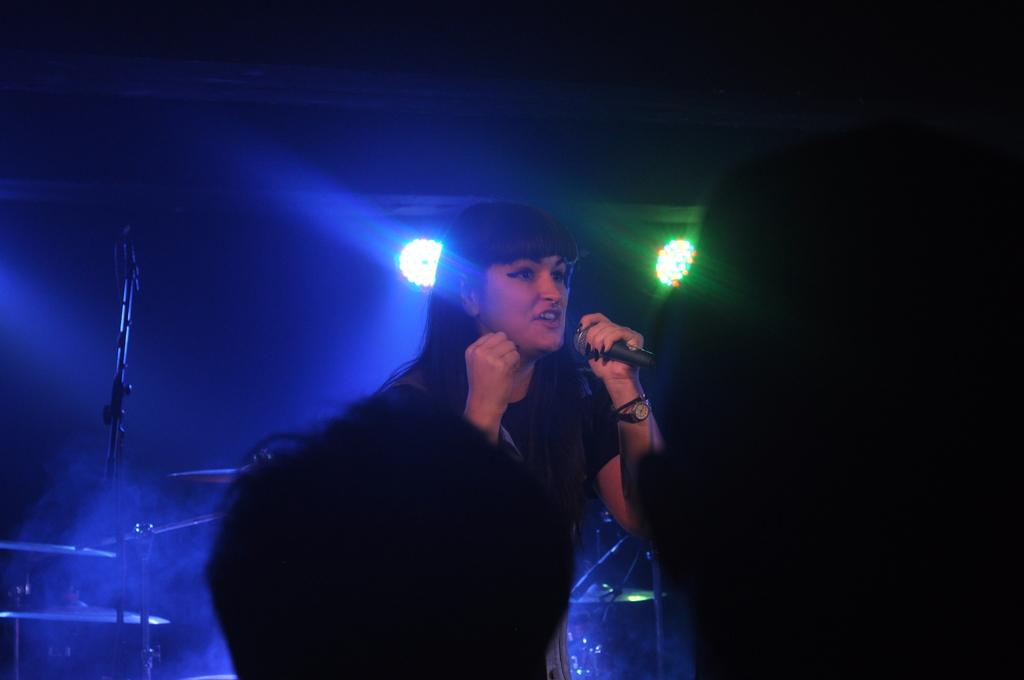What is the person in the image doing? The person is standing and holding a microphone. Can you describe the presence of other people in the image? A: There are two other people's heads visible in the image. What can be seen in the background of the image? There are lights in the background of the image. What type of basket is being used for the volleyball game in the image? There is no volleyball game or basket present in the image. What angle is the camera positioned at to capture the image? The angle of the camera is not mentioned in the image, as we are only looking at the image directly and not considering the camera's position. 